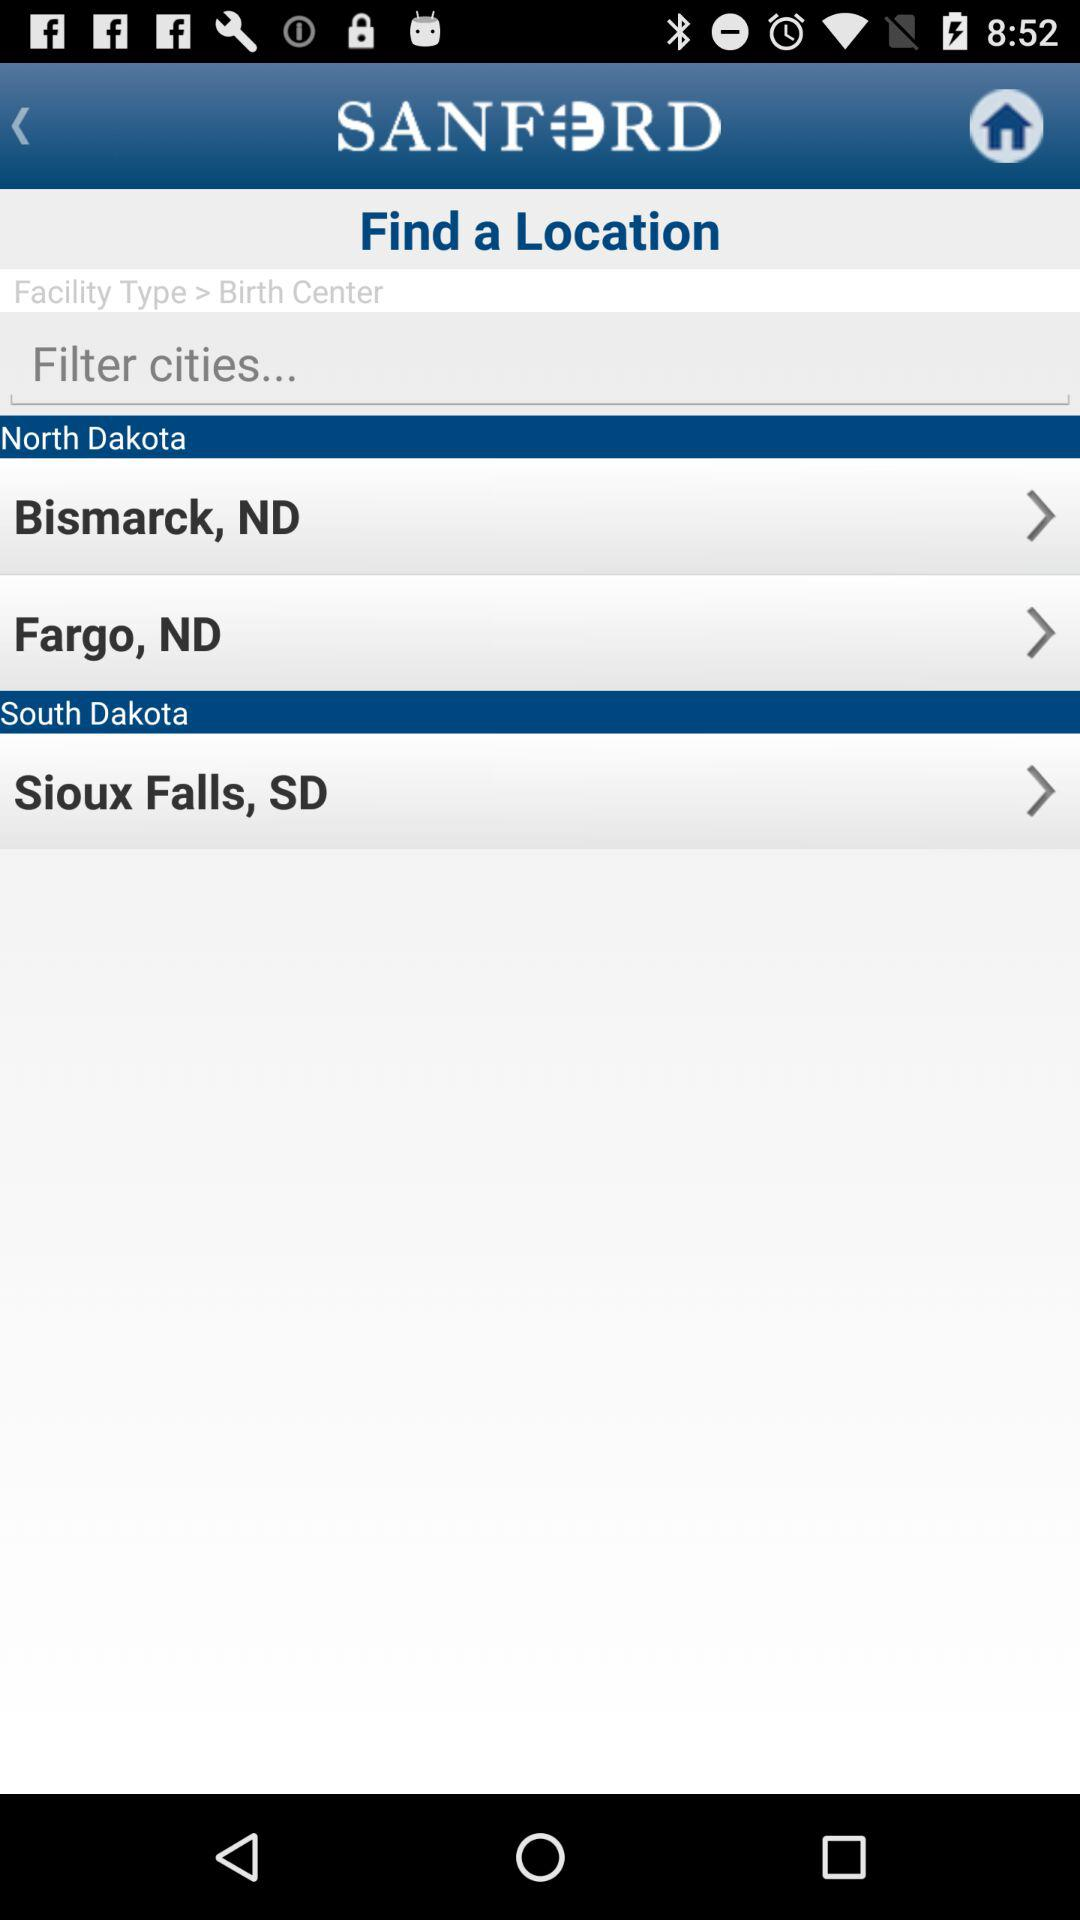What is the name of the birth center?
When the provided information is insufficient, respond with <no answer>. <no answer> 